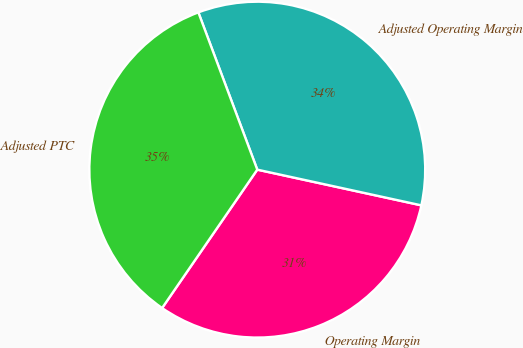<chart> <loc_0><loc_0><loc_500><loc_500><pie_chart><fcel>Operating Margin<fcel>Adjusted Operating Margin<fcel>Adjusted PTC<nl><fcel>31.18%<fcel>34.12%<fcel>34.71%<nl></chart> 